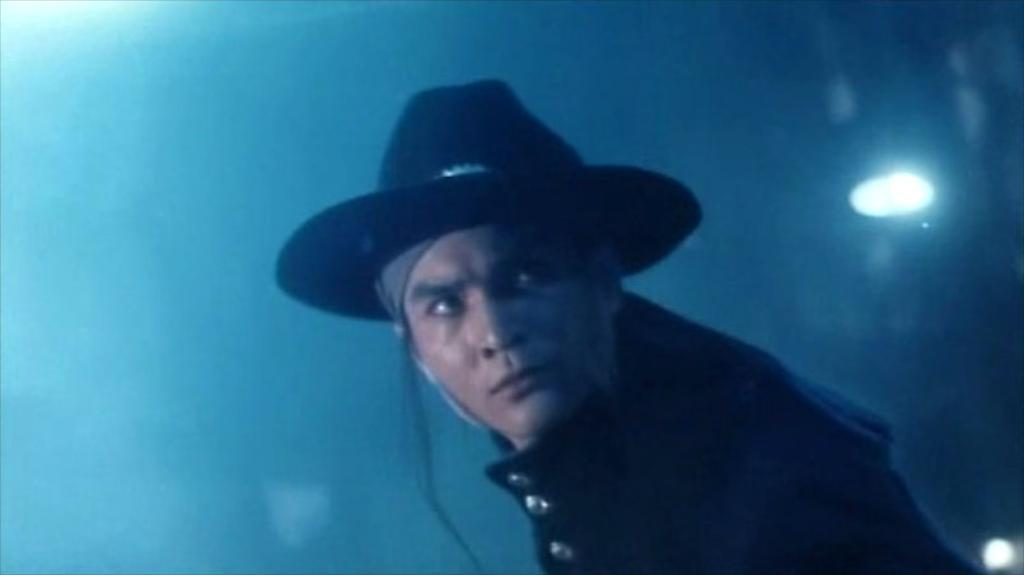What is the main subject of the image? There is a person in the image. Can you describe the background of the image? The background of the image is blurred. What else can be seen in the image besides the person? There are lights visible in the image. What type of metal is used to create the calendar in the image? There is no calendar present in the image, so it is not possible to determine what type of metal might be used. 